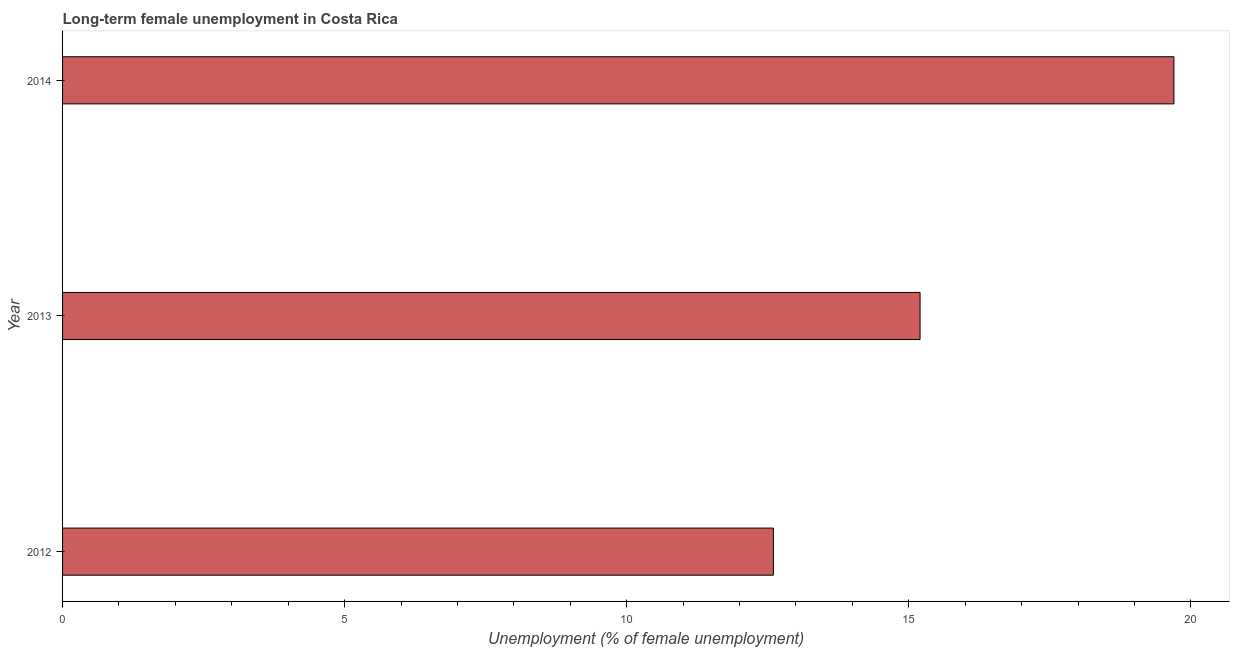What is the title of the graph?
Make the answer very short. Long-term female unemployment in Costa Rica. What is the label or title of the X-axis?
Offer a terse response. Unemployment (% of female unemployment). What is the long-term female unemployment in 2014?
Offer a terse response. 19.7. Across all years, what is the maximum long-term female unemployment?
Offer a very short reply. 19.7. Across all years, what is the minimum long-term female unemployment?
Offer a terse response. 12.6. In which year was the long-term female unemployment maximum?
Your answer should be compact. 2014. What is the sum of the long-term female unemployment?
Give a very brief answer. 47.5. What is the average long-term female unemployment per year?
Provide a succinct answer. 15.83. What is the median long-term female unemployment?
Offer a terse response. 15.2. What is the ratio of the long-term female unemployment in 2013 to that in 2014?
Your answer should be compact. 0.77. Is the sum of the long-term female unemployment in 2012 and 2014 greater than the maximum long-term female unemployment across all years?
Offer a very short reply. Yes. What is the difference between the highest and the lowest long-term female unemployment?
Your response must be concise. 7.1. In how many years, is the long-term female unemployment greater than the average long-term female unemployment taken over all years?
Offer a very short reply. 1. How many bars are there?
Ensure brevity in your answer.  3. What is the difference between two consecutive major ticks on the X-axis?
Ensure brevity in your answer.  5. What is the Unemployment (% of female unemployment) in 2012?
Provide a short and direct response. 12.6. What is the Unemployment (% of female unemployment) in 2013?
Your answer should be very brief. 15.2. What is the Unemployment (% of female unemployment) in 2014?
Keep it short and to the point. 19.7. What is the difference between the Unemployment (% of female unemployment) in 2012 and 2013?
Offer a terse response. -2.6. What is the difference between the Unemployment (% of female unemployment) in 2012 and 2014?
Your response must be concise. -7.1. What is the difference between the Unemployment (% of female unemployment) in 2013 and 2014?
Your answer should be very brief. -4.5. What is the ratio of the Unemployment (% of female unemployment) in 2012 to that in 2013?
Make the answer very short. 0.83. What is the ratio of the Unemployment (% of female unemployment) in 2012 to that in 2014?
Offer a terse response. 0.64. What is the ratio of the Unemployment (% of female unemployment) in 2013 to that in 2014?
Keep it short and to the point. 0.77. 